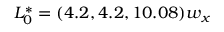<formula> <loc_0><loc_0><loc_500><loc_500>L _ { 0 } ^ { * } = ( 4 . 2 , 4 . 2 , 1 0 . 0 8 ) w _ { x }</formula> 